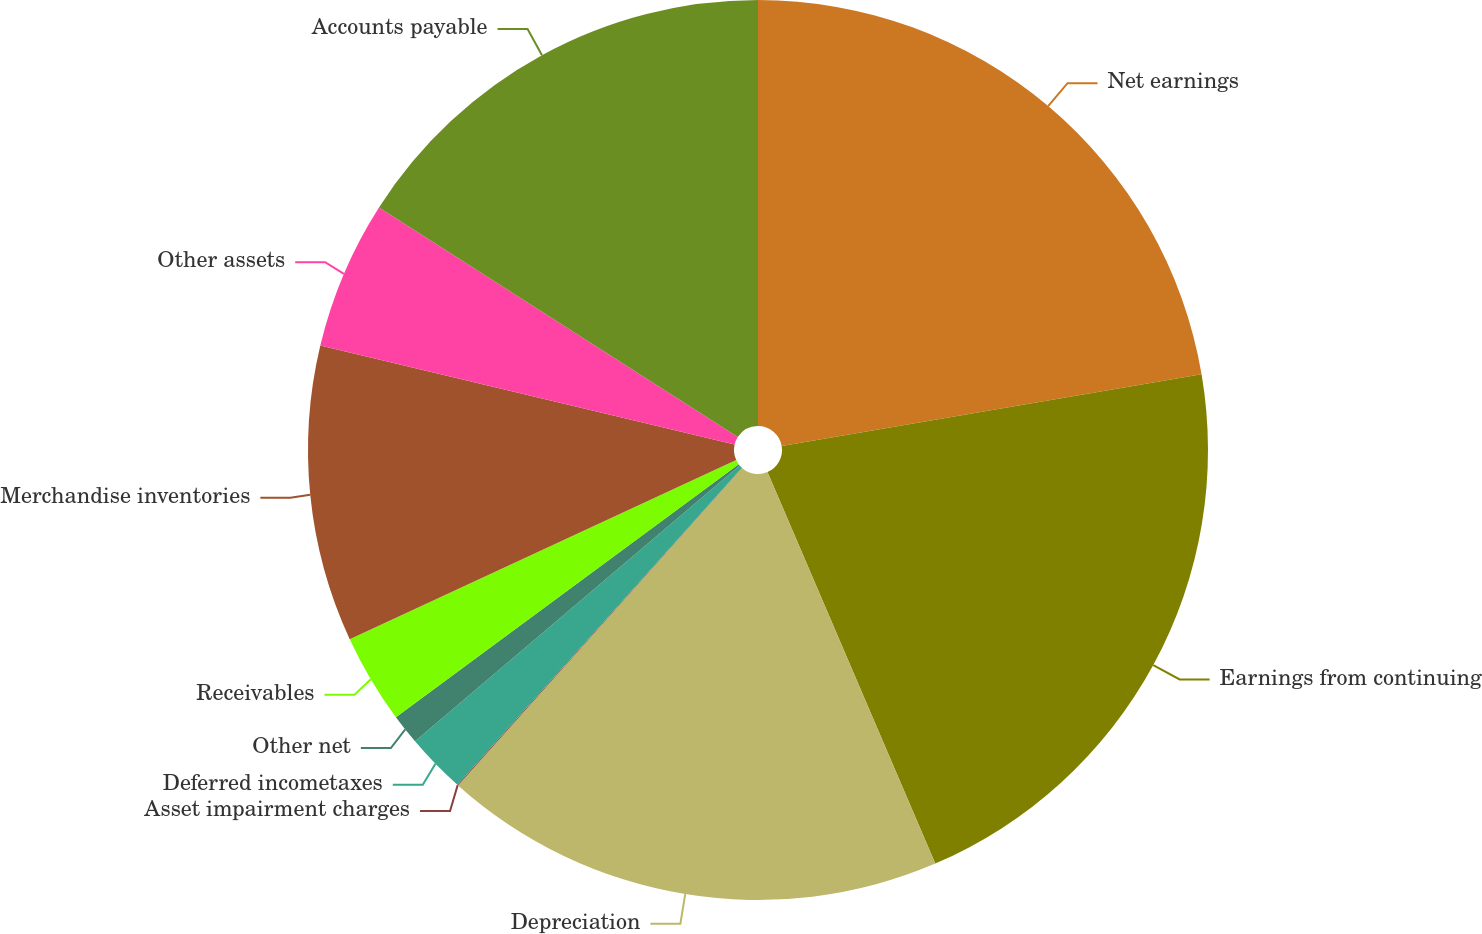Convert chart to OTSL. <chart><loc_0><loc_0><loc_500><loc_500><pie_chart><fcel>Net earnings<fcel>Earnings from continuing<fcel>Depreciation<fcel>Asset impairment charges<fcel>Deferred incometaxes<fcel>Other net<fcel>Receivables<fcel>Merchandise inventories<fcel>Other assets<fcel>Accounts payable<nl><fcel>22.31%<fcel>21.25%<fcel>18.06%<fcel>0.03%<fcel>2.15%<fcel>1.09%<fcel>3.21%<fcel>10.64%<fcel>5.33%<fcel>15.94%<nl></chart> 